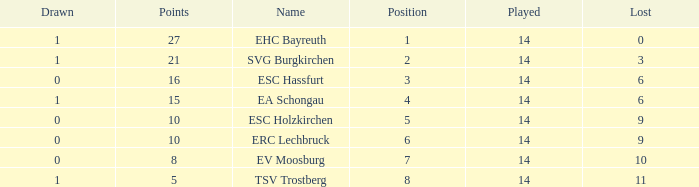What's the lost when there were more than 16 points and had a drawn less than 1? None. 